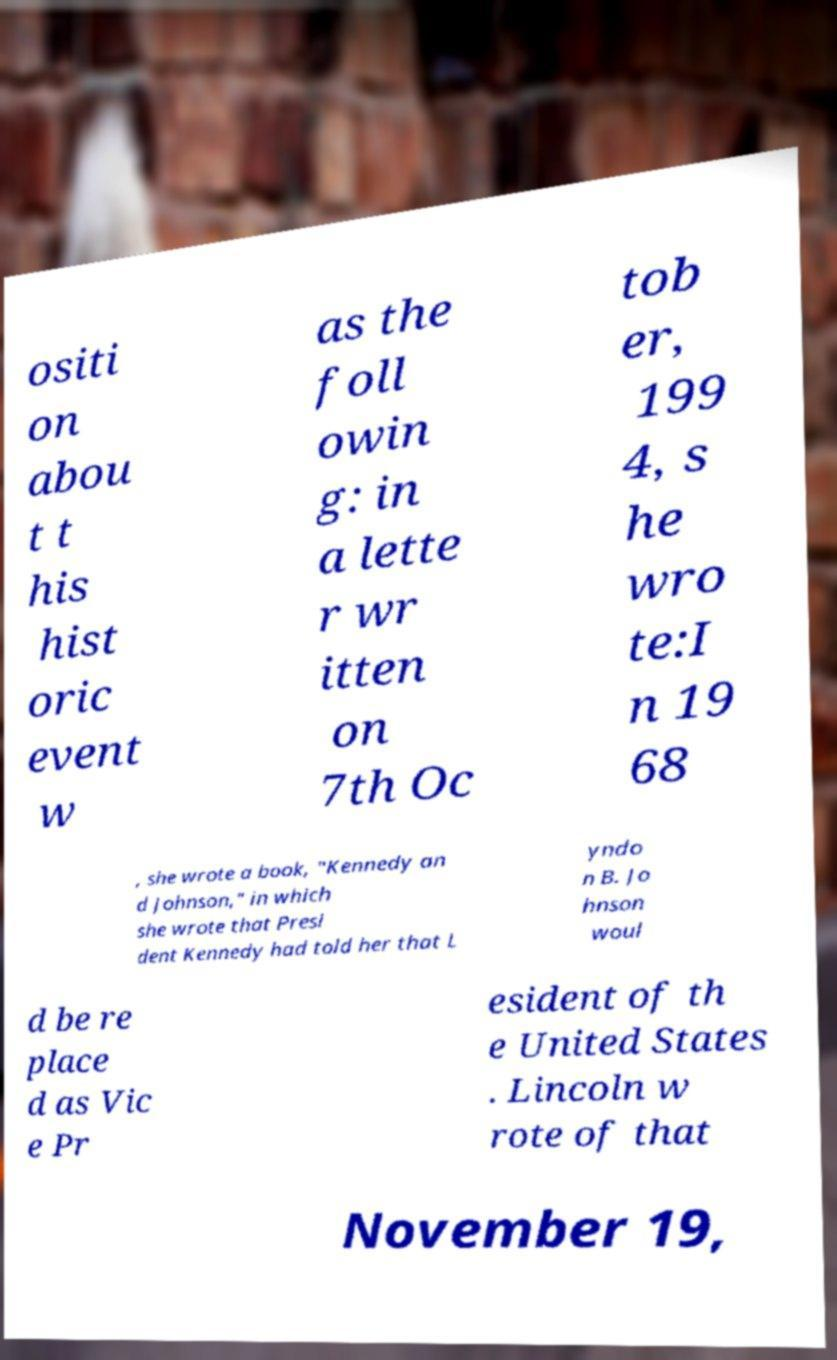For documentation purposes, I need the text within this image transcribed. Could you provide that? ositi on abou t t his hist oric event w as the foll owin g: in a lette r wr itten on 7th Oc tob er, 199 4, s he wro te:I n 19 68 , she wrote a book, "Kennedy an d Johnson," in which she wrote that Presi dent Kennedy had told her that L yndo n B. Jo hnson woul d be re place d as Vic e Pr esident of th e United States . Lincoln w rote of that November 19, 